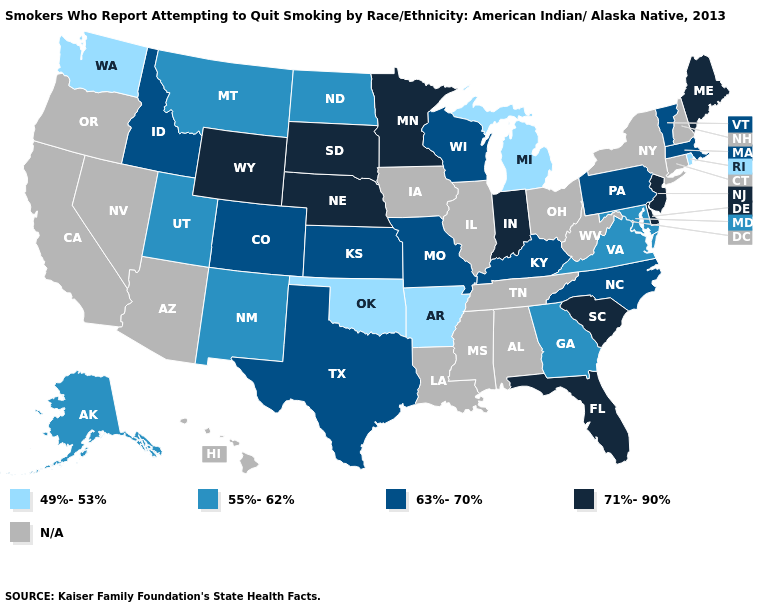What is the value of Montana?
Concise answer only. 55%-62%. Does the map have missing data?
Be succinct. Yes. Among the states that border West Virginia , does Maryland have the lowest value?
Keep it brief. Yes. What is the highest value in states that border Oklahoma?
Be succinct. 63%-70%. Among the states that border Illinois , which have the lowest value?
Quick response, please. Kentucky, Missouri, Wisconsin. What is the highest value in the West ?
Short answer required. 71%-90%. What is the value of Tennessee?
Quick response, please. N/A. What is the value of Iowa?
Give a very brief answer. N/A. What is the lowest value in the USA?
Answer briefly. 49%-53%. Does the map have missing data?
Be succinct. Yes. Which states have the highest value in the USA?
Concise answer only. Delaware, Florida, Indiana, Maine, Minnesota, Nebraska, New Jersey, South Carolina, South Dakota, Wyoming. Name the states that have a value in the range 63%-70%?
Be succinct. Colorado, Idaho, Kansas, Kentucky, Massachusetts, Missouri, North Carolina, Pennsylvania, Texas, Vermont, Wisconsin. What is the lowest value in the USA?
Give a very brief answer. 49%-53%. Does the map have missing data?
Answer briefly. Yes. Among the states that border Minnesota , does Wisconsin have the highest value?
Be succinct. No. 